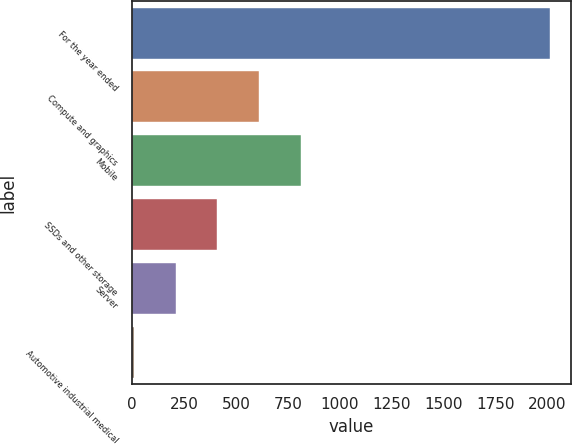Convert chart to OTSL. <chart><loc_0><loc_0><loc_500><loc_500><bar_chart><fcel>For the year ended<fcel>Compute and graphics<fcel>Mobile<fcel>SSDs and other storage<fcel>Server<fcel>Automotive industrial medical<nl><fcel>2015<fcel>611.5<fcel>812<fcel>411<fcel>210.5<fcel>10<nl></chart> 